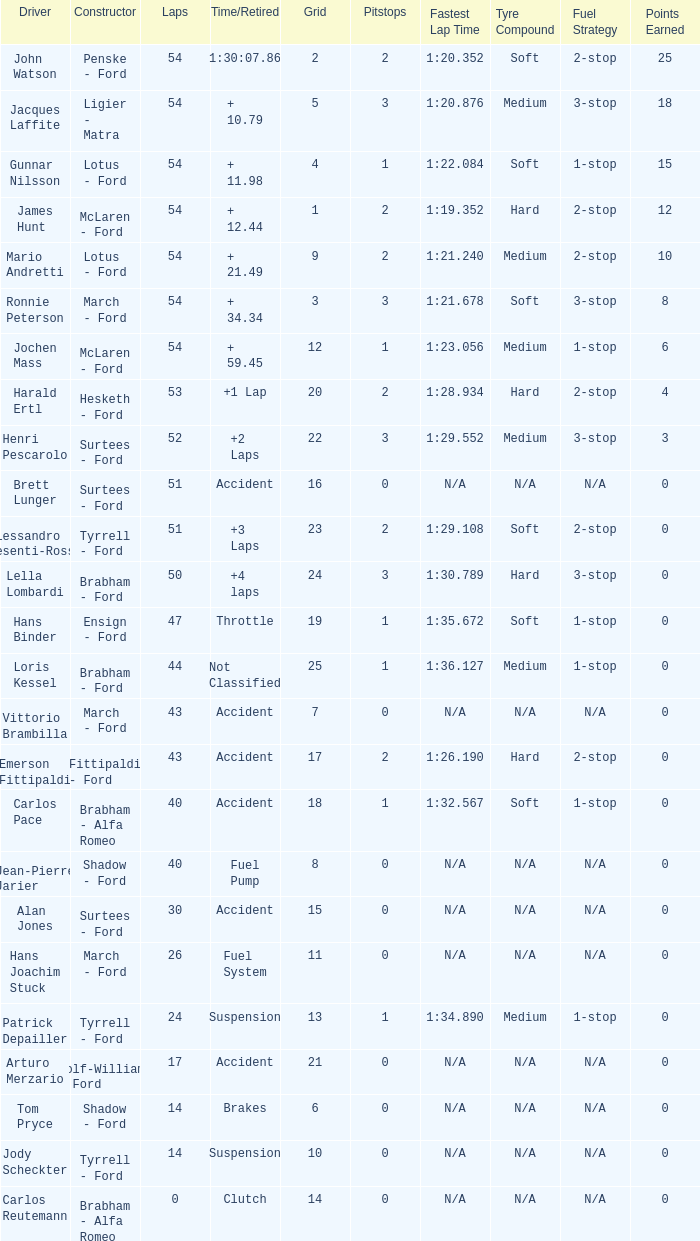What is the Time/Retired of Carlos Reutemann who was driving a brabham - Alfa Romeo? Clutch. 